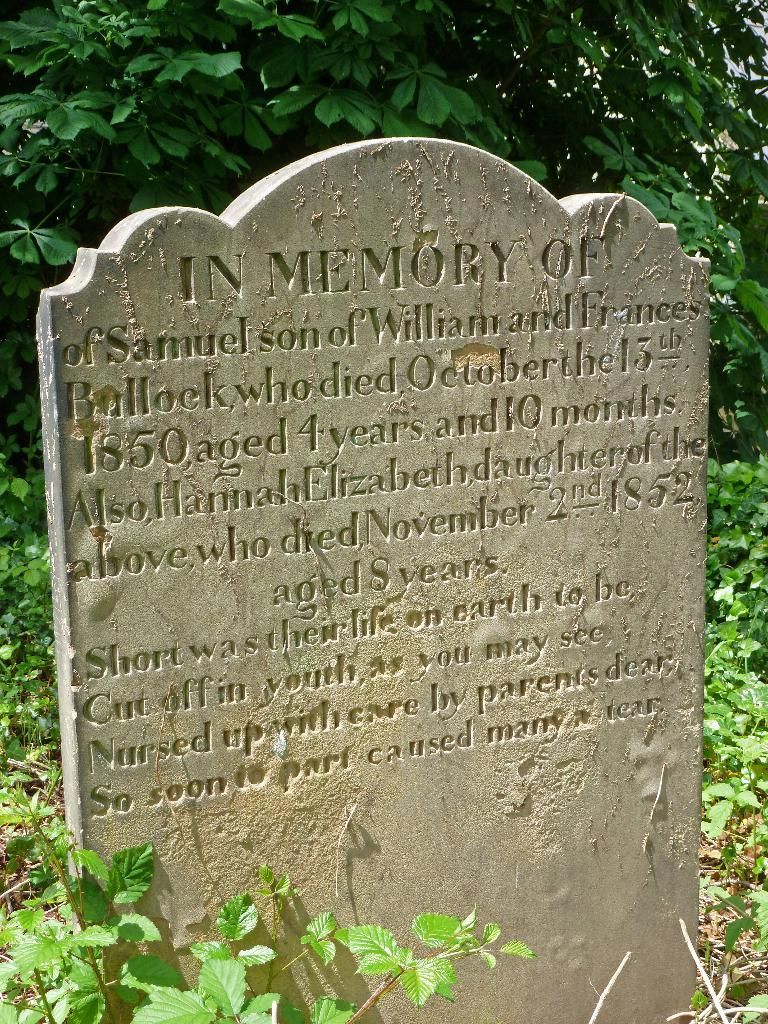What is the main subject of the image? There is a graveyard stone in the image. What can be found on the graveyard stone? There is writing on the graveyard stone. What can be seen in the background of the image? There are trees in the background of the image. What type of experience can be seen on the root of the son in the image? There is no root or son present in the image; it features a graveyard stone with writing and trees in the background. 